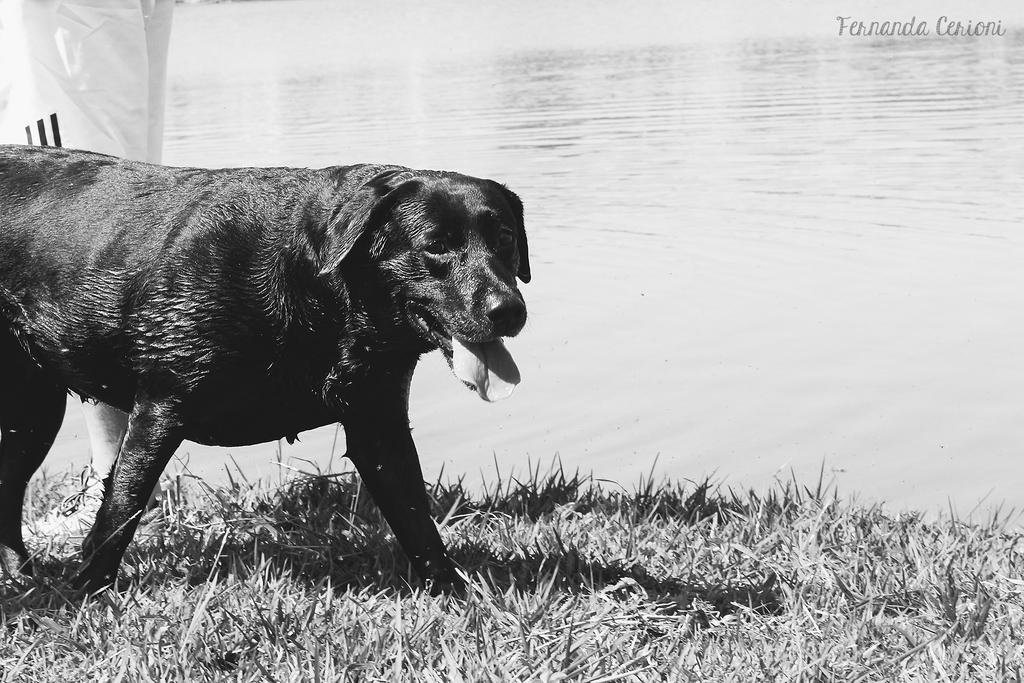What type of animal is present in the image? There is a dog in the image. What is the ground surface like in the image? There is grass on the ground in the image. What can be seen in the background of the image? There is water visible in the image. Where is the human located in the image? The human is on the left side of the image. What is present at the top right corner of the image? There is text at the top right corner of the image. What type of force is being applied to the dog in the image? There is no force being applied to the dog in the image; it is simply standing or sitting on the grass. What is the dog writing in the image? The dog is not writing anything in the image, as dogs do not have the ability to write. 